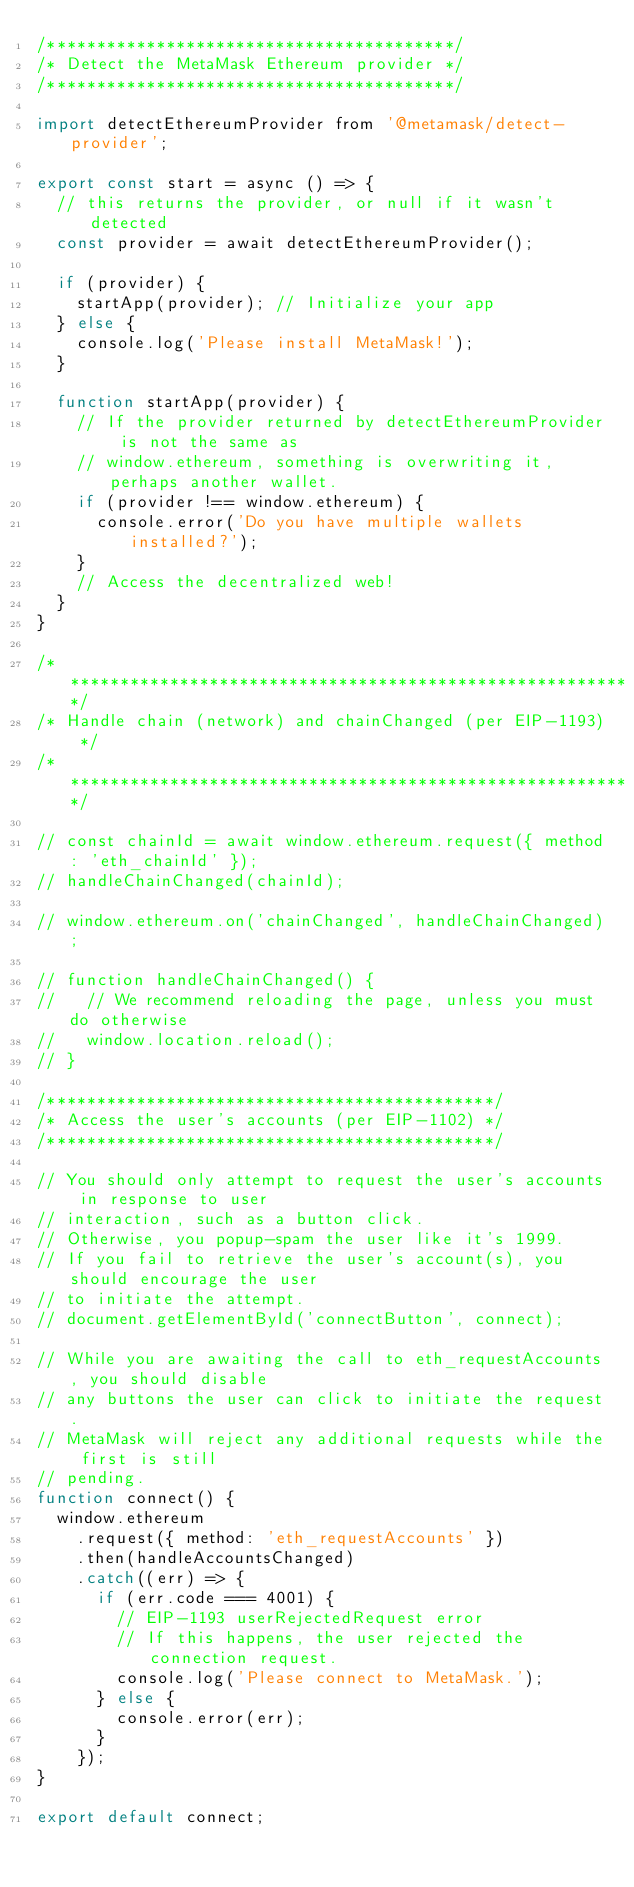Convert code to text. <code><loc_0><loc_0><loc_500><loc_500><_JavaScript_>/*****************************************/
/* Detect the MetaMask Ethereum provider */
/*****************************************/

import detectEthereumProvider from '@metamask/detect-provider';

export const start = async () => {
  // this returns the provider, or null if it wasn't detected
  const provider = await detectEthereumProvider();
  
  if (provider) {
    startApp(provider); // Initialize your app
  } else {
    console.log('Please install MetaMask!');
  }
  
  function startApp(provider) {
    // If the provider returned by detectEthereumProvider is not the same as
    // window.ethereum, something is overwriting it, perhaps another wallet.
    if (provider !== window.ethereum) {
      console.error('Do you have multiple wallets installed?');
    }
    // Access the decentralized web!
  }
}

/**********************************************************/
/* Handle chain (network) and chainChanged (per EIP-1193) */
/**********************************************************/

// const chainId = await window.ethereum.request({ method: 'eth_chainId' });
// handleChainChanged(chainId);

// window.ethereum.on('chainChanged', handleChainChanged);

// function handleChainChanged() {
//   // We recommend reloading the page, unless you must do otherwise
//   window.location.reload();
// }

/*********************************************/
/* Access the user's accounts (per EIP-1102) */
/*********************************************/

// You should only attempt to request the user's accounts in response to user
// interaction, such as a button click.
// Otherwise, you popup-spam the user like it's 1999.
// If you fail to retrieve the user's account(s), you should encourage the user
// to initiate the attempt.
// document.getElementById('connectButton', connect);

// While you are awaiting the call to eth_requestAccounts, you should disable
// any buttons the user can click to initiate the request.
// MetaMask will reject any additional requests while the first is still
// pending.
function connect() {
  window.ethereum
    .request({ method: 'eth_requestAccounts' })
    .then(handleAccountsChanged)
    .catch((err) => {
      if (err.code === 4001) {
        // EIP-1193 userRejectedRequest error
        // If this happens, the user rejected the connection request.
        console.log('Please connect to MetaMask.');
      } else {
        console.error(err);
      }
    });
}

export default connect;
</code> 